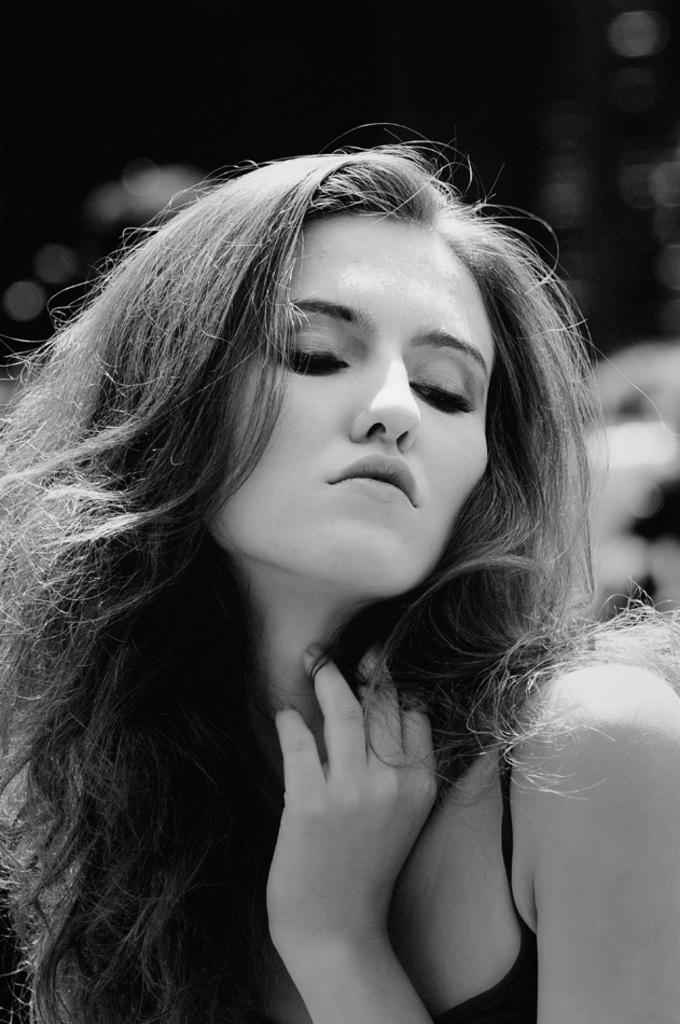What is the color scheme of the image? The image is black and white. Who is present in the image? There is a woman in the image. What is the woman doing in the image? The woman is posing for a photo. What is the color of the background in the image? The background of the image is black in color. How is the background of the image depicted? The background of the image is blurred. What type of kite is the woman holding in the image? There is no kite present in the image; the woman is posing for a photo. What kind of party is being depicted in the image? There is no party depicted in the image; it is a black and white photo of a woman posing. 